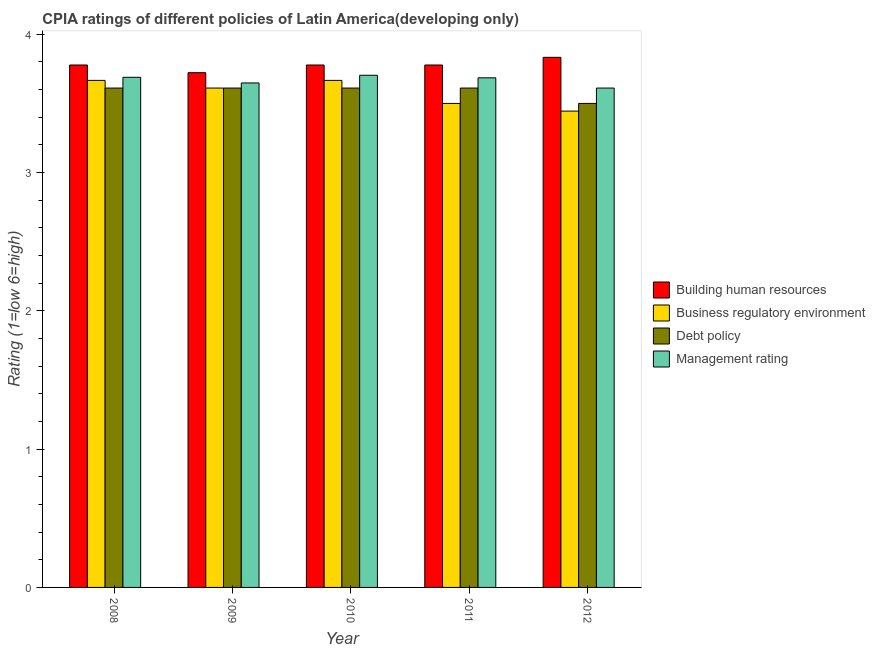How many groups of bars are there?
Offer a very short reply. 5. Are the number of bars per tick equal to the number of legend labels?
Offer a very short reply. Yes. How many bars are there on the 1st tick from the right?
Your response must be concise. 4. What is the label of the 2nd group of bars from the left?
Keep it short and to the point. 2009. In how many cases, is the number of bars for a given year not equal to the number of legend labels?
Provide a succinct answer. 0. What is the cpia rating of management in 2011?
Make the answer very short. 3.69. Across all years, what is the maximum cpia rating of business regulatory environment?
Give a very brief answer. 3.67. Across all years, what is the minimum cpia rating of management?
Your response must be concise. 3.61. What is the total cpia rating of debt policy in the graph?
Make the answer very short. 17.94. What is the difference between the cpia rating of debt policy in 2009 and that in 2012?
Ensure brevity in your answer.  0.11. What is the difference between the cpia rating of management in 2010 and the cpia rating of business regulatory environment in 2011?
Provide a succinct answer. 0.02. What is the average cpia rating of debt policy per year?
Your answer should be compact. 3.59. In how many years, is the cpia rating of debt policy greater than 2?
Your response must be concise. 5. Is the difference between the cpia rating of management in 2009 and 2011 greater than the difference between the cpia rating of business regulatory environment in 2009 and 2011?
Provide a short and direct response. No. What is the difference between the highest and the lowest cpia rating of business regulatory environment?
Your answer should be very brief. 0.22. Is the sum of the cpia rating of business regulatory environment in 2008 and 2009 greater than the maximum cpia rating of management across all years?
Your answer should be compact. Yes. What does the 1st bar from the left in 2012 represents?
Give a very brief answer. Building human resources. What does the 2nd bar from the right in 2012 represents?
Ensure brevity in your answer.  Debt policy. How many bars are there?
Give a very brief answer. 20. Are all the bars in the graph horizontal?
Provide a succinct answer. No. What is the difference between two consecutive major ticks on the Y-axis?
Your response must be concise. 1. Does the graph contain any zero values?
Keep it short and to the point. No. Where does the legend appear in the graph?
Your answer should be very brief. Center right. What is the title of the graph?
Ensure brevity in your answer.  CPIA ratings of different policies of Latin America(developing only). What is the label or title of the X-axis?
Give a very brief answer. Year. What is the Rating (1=low 6=high) of Building human resources in 2008?
Offer a terse response. 3.78. What is the Rating (1=low 6=high) of Business regulatory environment in 2008?
Keep it short and to the point. 3.67. What is the Rating (1=low 6=high) in Debt policy in 2008?
Give a very brief answer. 3.61. What is the Rating (1=low 6=high) of Management rating in 2008?
Your answer should be very brief. 3.69. What is the Rating (1=low 6=high) in Building human resources in 2009?
Your answer should be compact. 3.72. What is the Rating (1=low 6=high) of Business regulatory environment in 2009?
Provide a succinct answer. 3.61. What is the Rating (1=low 6=high) of Debt policy in 2009?
Provide a short and direct response. 3.61. What is the Rating (1=low 6=high) of Management rating in 2009?
Ensure brevity in your answer.  3.65. What is the Rating (1=low 6=high) in Building human resources in 2010?
Your answer should be very brief. 3.78. What is the Rating (1=low 6=high) in Business regulatory environment in 2010?
Your answer should be very brief. 3.67. What is the Rating (1=low 6=high) of Debt policy in 2010?
Keep it short and to the point. 3.61. What is the Rating (1=low 6=high) in Management rating in 2010?
Offer a terse response. 3.7. What is the Rating (1=low 6=high) in Building human resources in 2011?
Provide a short and direct response. 3.78. What is the Rating (1=low 6=high) in Debt policy in 2011?
Offer a very short reply. 3.61. What is the Rating (1=low 6=high) of Management rating in 2011?
Give a very brief answer. 3.69. What is the Rating (1=low 6=high) in Building human resources in 2012?
Make the answer very short. 3.83. What is the Rating (1=low 6=high) of Business regulatory environment in 2012?
Provide a short and direct response. 3.44. What is the Rating (1=low 6=high) in Debt policy in 2012?
Offer a very short reply. 3.5. What is the Rating (1=low 6=high) in Management rating in 2012?
Ensure brevity in your answer.  3.61. Across all years, what is the maximum Rating (1=low 6=high) of Building human resources?
Make the answer very short. 3.83. Across all years, what is the maximum Rating (1=low 6=high) of Business regulatory environment?
Keep it short and to the point. 3.67. Across all years, what is the maximum Rating (1=low 6=high) in Debt policy?
Your answer should be very brief. 3.61. Across all years, what is the maximum Rating (1=low 6=high) in Management rating?
Offer a very short reply. 3.7. Across all years, what is the minimum Rating (1=low 6=high) in Building human resources?
Provide a short and direct response. 3.72. Across all years, what is the minimum Rating (1=low 6=high) in Business regulatory environment?
Provide a short and direct response. 3.44. Across all years, what is the minimum Rating (1=low 6=high) in Management rating?
Your answer should be compact. 3.61. What is the total Rating (1=low 6=high) in Building human resources in the graph?
Make the answer very short. 18.89. What is the total Rating (1=low 6=high) in Business regulatory environment in the graph?
Keep it short and to the point. 17.89. What is the total Rating (1=low 6=high) of Debt policy in the graph?
Ensure brevity in your answer.  17.94. What is the total Rating (1=low 6=high) in Management rating in the graph?
Give a very brief answer. 18.34. What is the difference between the Rating (1=low 6=high) of Building human resources in 2008 and that in 2009?
Your answer should be compact. 0.06. What is the difference between the Rating (1=low 6=high) in Business regulatory environment in 2008 and that in 2009?
Make the answer very short. 0.06. What is the difference between the Rating (1=low 6=high) in Debt policy in 2008 and that in 2009?
Make the answer very short. 0. What is the difference between the Rating (1=low 6=high) in Management rating in 2008 and that in 2009?
Give a very brief answer. 0.04. What is the difference between the Rating (1=low 6=high) of Business regulatory environment in 2008 and that in 2010?
Make the answer very short. 0. What is the difference between the Rating (1=low 6=high) in Management rating in 2008 and that in 2010?
Your answer should be very brief. -0.01. What is the difference between the Rating (1=low 6=high) in Management rating in 2008 and that in 2011?
Provide a short and direct response. 0. What is the difference between the Rating (1=low 6=high) of Building human resources in 2008 and that in 2012?
Your answer should be compact. -0.06. What is the difference between the Rating (1=low 6=high) of Business regulatory environment in 2008 and that in 2012?
Make the answer very short. 0.22. What is the difference between the Rating (1=low 6=high) of Debt policy in 2008 and that in 2012?
Ensure brevity in your answer.  0.11. What is the difference between the Rating (1=low 6=high) in Management rating in 2008 and that in 2012?
Ensure brevity in your answer.  0.08. What is the difference between the Rating (1=low 6=high) of Building human resources in 2009 and that in 2010?
Ensure brevity in your answer.  -0.06. What is the difference between the Rating (1=low 6=high) of Business regulatory environment in 2009 and that in 2010?
Your answer should be very brief. -0.06. What is the difference between the Rating (1=low 6=high) of Debt policy in 2009 and that in 2010?
Give a very brief answer. 0. What is the difference between the Rating (1=low 6=high) of Management rating in 2009 and that in 2010?
Offer a terse response. -0.06. What is the difference between the Rating (1=low 6=high) in Building human resources in 2009 and that in 2011?
Provide a short and direct response. -0.06. What is the difference between the Rating (1=low 6=high) in Management rating in 2009 and that in 2011?
Keep it short and to the point. -0.04. What is the difference between the Rating (1=low 6=high) of Building human resources in 2009 and that in 2012?
Offer a very short reply. -0.11. What is the difference between the Rating (1=low 6=high) in Management rating in 2009 and that in 2012?
Offer a very short reply. 0.04. What is the difference between the Rating (1=low 6=high) of Management rating in 2010 and that in 2011?
Make the answer very short. 0.02. What is the difference between the Rating (1=low 6=high) in Building human resources in 2010 and that in 2012?
Provide a succinct answer. -0.06. What is the difference between the Rating (1=low 6=high) of Business regulatory environment in 2010 and that in 2012?
Your answer should be compact. 0.22. What is the difference between the Rating (1=low 6=high) of Management rating in 2010 and that in 2012?
Provide a short and direct response. 0.09. What is the difference between the Rating (1=low 6=high) of Building human resources in 2011 and that in 2012?
Ensure brevity in your answer.  -0.06. What is the difference between the Rating (1=low 6=high) of Business regulatory environment in 2011 and that in 2012?
Provide a succinct answer. 0.06. What is the difference between the Rating (1=low 6=high) in Debt policy in 2011 and that in 2012?
Offer a terse response. 0.11. What is the difference between the Rating (1=low 6=high) of Management rating in 2011 and that in 2012?
Keep it short and to the point. 0.07. What is the difference between the Rating (1=low 6=high) of Building human resources in 2008 and the Rating (1=low 6=high) of Business regulatory environment in 2009?
Provide a succinct answer. 0.17. What is the difference between the Rating (1=low 6=high) of Building human resources in 2008 and the Rating (1=low 6=high) of Management rating in 2009?
Make the answer very short. 0.13. What is the difference between the Rating (1=low 6=high) in Business regulatory environment in 2008 and the Rating (1=low 6=high) in Debt policy in 2009?
Your response must be concise. 0.06. What is the difference between the Rating (1=low 6=high) of Business regulatory environment in 2008 and the Rating (1=low 6=high) of Management rating in 2009?
Ensure brevity in your answer.  0.02. What is the difference between the Rating (1=low 6=high) in Debt policy in 2008 and the Rating (1=low 6=high) in Management rating in 2009?
Offer a terse response. -0.04. What is the difference between the Rating (1=low 6=high) in Building human resources in 2008 and the Rating (1=low 6=high) in Debt policy in 2010?
Your response must be concise. 0.17. What is the difference between the Rating (1=low 6=high) of Building human resources in 2008 and the Rating (1=low 6=high) of Management rating in 2010?
Your answer should be compact. 0.07. What is the difference between the Rating (1=low 6=high) of Business regulatory environment in 2008 and the Rating (1=low 6=high) of Debt policy in 2010?
Give a very brief answer. 0.06. What is the difference between the Rating (1=low 6=high) of Business regulatory environment in 2008 and the Rating (1=low 6=high) of Management rating in 2010?
Provide a short and direct response. -0.04. What is the difference between the Rating (1=low 6=high) in Debt policy in 2008 and the Rating (1=low 6=high) in Management rating in 2010?
Offer a terse response. -0.09. What is the difference between the Rating (1=low 6=high) of Building human resources in 2008 and the Rating (1=low 6=high) of Business regulatory environment in 2011?
Ensure brevity in your answer.  0.28. What is the difference between the Rating (1=low 6=high) of Building human resources in 2008 and the Rating (1=low 6=high) of Management rating in 2011?
Keep it short and to the point. 0.09. What is the difference between the Rating (1=low 6=high) in Business regulatory environment in 2008 and the Rating (1=low 6=high) in Debt policy in 2011?
Provide a succinct answer. 0.06. What is the difference between the Rating (1=low 6=high) in Business regulatory environment in 2008 and the Rating (1=low 6=high) in Management rating in 2011?
Your response must be concise. -0.02. What is the difference between the Rating (1=low 6=high) in Debt policy in 2008 and the Rating (1=low 6=high) in Management rating in 2011?
Offer a very short reply. -0.07. What is the difference between the Rating (1=low 6=high) in Building human resources in 2008 and the Rating (1=low 6=high) in Business regulatory environment in 2012?
Your answer should be compact. 0.33. What is the difference between the Rating (1=low 6=high) of Building human resources in 2008 and the Rating (1=low 6=high) of Debt policy in 2012?
Provide a succinct answer. 0.28. What is the difference between the Rating (1=low 6=high) in Building human resources in 2008 and the Rating (1=low 6=high) in Management rating in 2012?
Your answer should be very brief. 0.17. What is the difference between the Rating (1=low 6=high) of Business regulatory environment in 2008 and the Rating (1=low 6=high) of Management rating in 2012?
Keep it short and to the point. 0.06. What is the difference between the Rating (1=low 6=high) of Debt policy in 2008 and the Rating (1=low 6=high) of Management rating in 2012?
Give a very brief answer. 0. What is the difference between the Rating (1=low 6=high) in Building human resources in 2009 and the Rating (1=low 6=high) in Business regulatory environment in 2010?
Offer a very short reply. 0.06. What is the difference between the Rating (1=low 6=high) in Building human resources in 2009 and the Rating (1=low 6=high) in Management rating in 2010?
Your answer should be very brief. 0.02. What is the difference between the Rating (1=low 6=high) in Business regulatory environment in 2009 and the Rating (1=low 6=high) in Management rating in 2010?
Ensure brevity in your answer.  -0.09. What is the difference between the Rating (1=low 6=high) in Debt policy in 2009 and the Rating (1=low 6=high) in Management rating in 2010?
Your answer should be very brief. -0.09. What is the difference between the Rating (1=low 6=high) of Building human resources in 2009 and the Rating (1=low 6=high) of Business regulatory environment in 2011?
Offer a very short reply. 0.22. What is the difference between the Rating (1=low 6=high) in Building human resources in 2009 and the Rating (1=low 6=high) in Debt policy in 2011?
Offer a very short reply. 0.11. What is the difference between the Rating (1=low 6=high) in Building human resources in 2009 and the Rating (1=low 6=high) in Management rating in 2011?
Offer a terse response. 0.04. What is the difference between the Rating (1=low 6=high) in Business regulatory environment in 2009 and the Rating (1=low 6=high) in Debt policy in 2011?
Provide a succinct answer. 0. What is the difference between the Rating (1=low 6=high) of Business regulatory environment in 2009 and the Rating (1=low 6=high) of Management rating in 2011?
Offer a very short reply. -0.07. What is the difference between the Rating (1=low 6=high) in Debt policy in 2009 and the Rating (1=low 6=high) in Management rating in 2011?
Give a very brief answer. -0.07. What is the difference between the Rating (1=low 6=high) in Building human resources in 2009 and the Rating (1=low 6=high) in Business regulatory environment in 2012?
Offer a very short reply. 0.28. What is the difference between the Rating (1=low 6=high) of Building human resources in 2009 and the Rating (1=low 6=high) of Debt policy in 2012?
Offer a very short reply. 0.22. What is the difference between the Rating (1=low 6=high) in Building human resources in 2009 and the Rating (1=low 6=high) in Management rating in 2012?
Offer a very short reply. 0.11. What is the difference between the Rating (1=low 6=high) of Business regulatory environment in 2009 and the Rating (1=low 6=high) of Debt policy in 2012?
Your answer should be compact. 0.11. What is the difference between the Rating (1=low 6=high) in Business regulatory environment in 2009 and the Rating (1=low 6=high) in Management rating in 2012?
Offer a very short reply. 0. What is the difference between the Rating (1=low 6=high) of Debt policy in 2009 and the Rating (1=low 6=high) of Management rating in 2012?
Give a very brief answer. 0. What is the difference between the Rating (1=low 6=high) of Building human resources in 2010 and the Rating (1=low 6=high) of Business regulatory environment in 2011?
Your response must be concise. 0.28. What is the difference between the Rating (1=low 6=high) of Building human resources in 2010 and the Rating (1=low 6=high) of Management rating in 2011?
Ensure brevity in your answer.  0.09. What is the difference between the Rating (1=low 6=high) of Business regulatory environment in 2010 and the Rating (1=low 6=high) of Debt policy in 2011?
Provide a short and direct response. 0.06. What is the difference between the Rating (1=low 6=high) in Business regulatory environment in 2010 and the Rating (1=low 6=high) in Management rating in 2011?
Your answer should be compact. -0.02. What is the difference between the Rating (1=low 6=high) of Debt policy in 2010 and the Rating (1=low 6=high) of Management rating in 2011?
Give a very brief answer. -0.07. What is the difference between the Rating (1=low 6=high) in Building human resources in 2010 and the Rating (1=low 6=high) in Debt policy in 2012?
Ensure brevity in your answer.  0.28. What is the difference between the Rating (1=low 6=high) of Business regulatory environment in 2010 and the Rating (1=low 6=high) of Management rating in 2012?
Make the answer very short. 0.06. What is the difference between the Rating (1=low 6=high) in Debt policy in 2010 and the Rating (1=low 6=high) in Management rating in 2012?
Keep it short and to the point. 0. What is the difference between the Rating (1=low 6=high) of Building human resources in 2011 and the Rating (1=low 6=high) of Debt policy in 2012?
Ensure brevity in your answer.  0.28. What is the difference between the Rating (1=low 6=high) in Business regulatory environment in 2011 and the Rating (1=low 6=high) in Management rating in 2012?
Your response must be concise. -0.11. What is the average Rating (1=low 6=high) of Building human resources per year?
Give a very brief answer. 3.78. What is the average Rating (1=low 6=high) of Business regulatory environment per year?
Keep it short and to the point. 3.58. What is the average Rating (1=low 6=high) in Debt policy per year?
Your answer should be very brief. 3.59. What is the average Rating (1=low 6=high) in Management rating per year?
Provide a succinct answer. 3.67. In the year 2008, what is the difference between the Rating (1=low 6=high) in Building human resources and Rating (1=low 6=high) in Debt policy?
Ensure brevity in your answer.  0.17. In the year 2008, what is the difference between the Rating (1=low 6=high) in Building human resources and Rating (1=low 6=high) in Management rating?
Offer a very short reply. 0.09. In the year 2008, what is the difference between the Rating (1=low 6=high) in Business regulatory environment and Rating (1=low 6=high) in Debt policy?
Make the answer very short. 0.06. In the year 2008, what is the difference between the Rating (1=low 6=high) of Business regulatory environment and Rating (1=low 6=high) of Management rating?
Give a very brief answer. -0.02. In the year 2008, what is the difference between the Rating (1=low 6=high) in Debt policy and Rating (1=low 6=high) in Management rating?
Offer a terse response. -0.08. In the year 2009, what is the difference between the Rating (1=low 6=high) in Building human resources and Rating (1=low 6=high) in Business regulatory environment?
Offer a terse response. 0.11. In the year 2009, what is the difference between the Rating (1=low 6=high) in Building human resources and Rating (1=low 6=high) in Management rating?
Offer a very short reply. 0.07. In the year 2009, what is the difference between the Rating (1=low 6=high) of Business regulatory environment and Rating (1=low 6=high) of Debt policy?
Offer a very short reply. 0. In the year 2009, what is the difference between the Rating (1=low 6=high) of Business regulatory environment and Rating (1=low 6=high) of Management rating?
Ensure brevity in your answer.  -0.04. In the year 2009, what is the difference between the Rating (1=low 6=high) in Debt policy and Rating (1=low 6=high) in Management rating?
Make the answer very short. -0.04. In the year 2010, what is the difference between the Rating (1=low 6=high) in Building human resources and Rating (1=low 6=high) in Business regulatory environment?
Provide a short and direct response. 0.11. In the year 2010, what is the difference between the Rating (1=low 6=high) of Building human resources and Rating (1=low 6=high) of Debt policy?
Ensure brevity in your answer.  0.17. In the year 2010, what is the difference between the Rating (1=low 6=high) of Building human resources and Rating (1=low 6=high) of Management rating?
Your response must be concise. 0.07. In the year 2010, what is the difference between the Rating (1=low 6=high) in Business regulatory environment and Rating (1=low 6=high) in Debt policy?
Ensure brevity in your answer.  0.06. In the year 2010, what is the difference between the Rating (1=low 6=high) of Business regulatory environment and Rating (1=low 6=high) of Management rating?
Keep it short and to the point. -0.04. In the year 2010, what is the difference between the Rating (1=low 6=high) of Debt policy and Rating (1=low 6=high) of Management rating?
Your answer should be compact. -0.09. In the year 2011, what is the difference between the Rating (1=low 6=high) of Building human resources and Rating (1=low 6=high) of Business regulatory environment?
Ensure brevity in your answer.  0.28. In the year 2011, what is the difference between the Rating (1=low 6=high) in Building human resources and Rating (1=low 6=high) in Management rating?
Keep it short and to the point. 0.09. In the year 2011, what is the difference between the Rating (1=low 6=high) in Business regulatory environment and Rating (1=low 6=high) in Debt policy?
Ensure brevity in your answer.  -0.11. In the year 2011, what is the difference between the Rating (1=low 6=high) of Business regulatory environment and Rating (1=low 6=high) of Management rating?
Keep it short and to the point. -0.19. In the year 2011, what is the difference between the Rating (1=low 6=high) of Debt policy and Rating (1=low 6=high) of Management rating?
Your response must be concise. -0.07. In the year 2012, what is the difference between the Rating (1=low 6=high) of Building human resources and Rating (1=low 6=high) of Business regulatory environment?
Keep it short and to the point. 0.39. In the year 2012, what is the difference between the Rating (1=low 6=high) of Building human resources and Rating (1=low 6=high) of Debt policy?
Make the answer very short. 0.33. In the year 2012, what is the difference between the Rating (1=low 6=high) in Building human resources and Rating (1=low 6=high) in Management rating?
Keep it short and to the point. 0.22. In the year 2012, what is the difference between the Rating (1=low 6=high) in Business regulatory environment and Rating (1=low 6=high) in Debt policy?
Keep it short and to the point. -0.06. In the year 2012, what is the difference between the Rating (1=low 6=high) of Debt policy and Rating (1=low 6=high) of Management rating?
Ensure brevity in your answer.  -0.11. What is the ratio of the Rating (1=low 6=high) of Building human resources in 2008 to that in 2009?
Offer a very short reply. 1.01. What is the ratio of the Rating (1=low 6=high) of Business regulatory environment in 2008 to that in 2009?
Give a very brief answer. 1.02. What is the ratio of the Rating (1=low 6=high) of Debt policy in 2008 to that in 2009?
Make the answer very short. 1. What is the ratio of the Rating (1=low 6=high) in Management rating in 2008 to that in 2009?
Your answer should be compact. 1.01. What is the ratio of the Rating (1=low 6=high) in Building human resources in 2008 to that in 2010?
Provide a short and direct response. 1. What is the ratio of the Rating (1=low 6=high) in Debt policy in 2008 to that in 2010?
Offer a very short reply. 1. What is the ratio of the Rating (1=low 6=high) in Building human resources in 2008 to that in 2011?
Provide a succinct answer. 1. What is the ratio of the Rating (1=low 6=high) in Business regulatory environment in 2008 to that in 2011?
Give a very brief answer. 1.05. What is the ratio of the Rating (1=low 6=high) in Debt policy in 2008 to that in 2011?
Offer a very short reply. 1. What is the ratio of the Rating (1=low 6=high) of Building human resources in 2008 to that in 2012?
Your answer should be compact. 0.99. What is the ratio of the Rating (1=low 6=high) of Business regulatory environment in 2008 to that in 2012?
Your answer should be very brief. 1.06. What is the ratio of the Rating (1=low 6=high) of Debt policy in 2008 to that in 2012?
Keep it short and to the point. 1.03. What is the ratio of the Rating (1=low 6=high) of Management rating in 2008 to that in 2012?
Provide a succinct answer. 1.02. What is the ratio of the Rating (1=low 6=high) in Building human resources in 2009 to that in 2010?
Provide a short and direct response. 0.99. What is the ratio of the Rating (1=low 6=high) of Management rating in 2009 to that in 2010?
Keep it short and to the point. 0.98. What is the ratio of the Rating (1=low 6=high) of Building human resources in 2009 to that in 2011?
Give a very brief answer. 0.99. What is the ratio of the Rating (1=low 6=high) in Business regulatory environment in 2009 to that in 2011?
Offer a very short reply. 1.03. What is the ratio of the Rating (1=low 6=high) of Debt policy in 2009 to that in 2011?
Provide a short and direct response. 1. What is the ratio of the Rating (1=low 6=high) in Management rating in 2009 to that in 2011?
Provide a succinct answer. 0.99. What is the ratio of the Rating (1=low 6=high) in Building human resources in 2009 to that in 2012?
Provide a succinct answer. 0.97. What is the ratio of the Rating (1=low 6=high) of Business regulatory environment in 2009 to that in 2012?
Ensure brevity in your answer.  1.05. What is the ratio of the Rating (1=low 6=high) in Debt policy in 2009 to that in 2012?
Provide a short and direct response. 1.03. What is the ratio of the Rating (1=low 6=high) in Management rating in 2009 to that in 2012?
Your answer should be compact. 1.01. What is the ratio of the Rating (1=low 6=high) in Building human resources in 2010 to that in 2011?
Provide a short and direct response. 1. What is the ratio of the Rating (1=low 6=high) in Business regulatory environment in 2010 to that in 2011?
Ensure brevity in your answer.  1.05. What is the ratio of the Rating (1=low 6=high) of Debt policy in 2010 to that in 2011?
Your answer should be very brief. 1. What is the ratio of the Rating (1=low 6=high) in Building human resources in 2010 to that in 2012?
Provide a succinct answer. 0.99. What is the ratio of the Rating (1=low 6=high) of Business regulatory environment in 2010 to that in 2012?
Make the answer very short. 1.06. What is the ratio of the Rating (1=low 6=high) in Debt policy in 2010 to that in 2012?
Your answer should be very brief. 1.03. What is the ratio of the Rating (1=low 6=high) of Management rating in 2010 to that in 2012?
Your answer should be very brief. 1.03. What is the ratio of the Rating (1=low 6=high) of Building human resources in 2011 to that in 2012?
Your response must be concise. 0.99. What is the ratio of the Rating (1=low 6=high) in Business regulatory environment in 2011 to that in 2012?
Give a very brief answer. 1.02. What is the ratio of the Rating (1=low 6=high) of Debt policy in 2011 to that in 2012?
Your response must be concise. 1.03. What is the ratio of the Rating (1=low 6=high) in Management rating in 2011 to that in 2012?
Your answer should be compact. 1.02. What is the difference between the highest and the second highest Rating (1=low 6=high) of Building human resources?
Offer a very short reply. 0.06. What is the difference between the highest and the second highest Rating (1=low 6=high) of Debt policy?
Offer a terse response. 0. What is the difference between the highest and the second highest Rating (1=low 6=high) of Management rating?
Your answer should be very brief. 0.01. What is the difference between the highest and the lowest Rating (1=low 6=high) in Building human resources?
Provide a short and direct response. 0.11. What is the difference between the highest and the lowest Rating (1=low 6=high) in Business regulatory environment?
Give a very brief answer. 0.22. What is the difference between the highest and the lowest Rating (1=low 6=high) in Debt policy?
Provide a short and direct response. 0.11. What is the difference between the highest and the lowest Rating (1=low 6=high) in Management rating?
Offer a terse response. 0.09. 